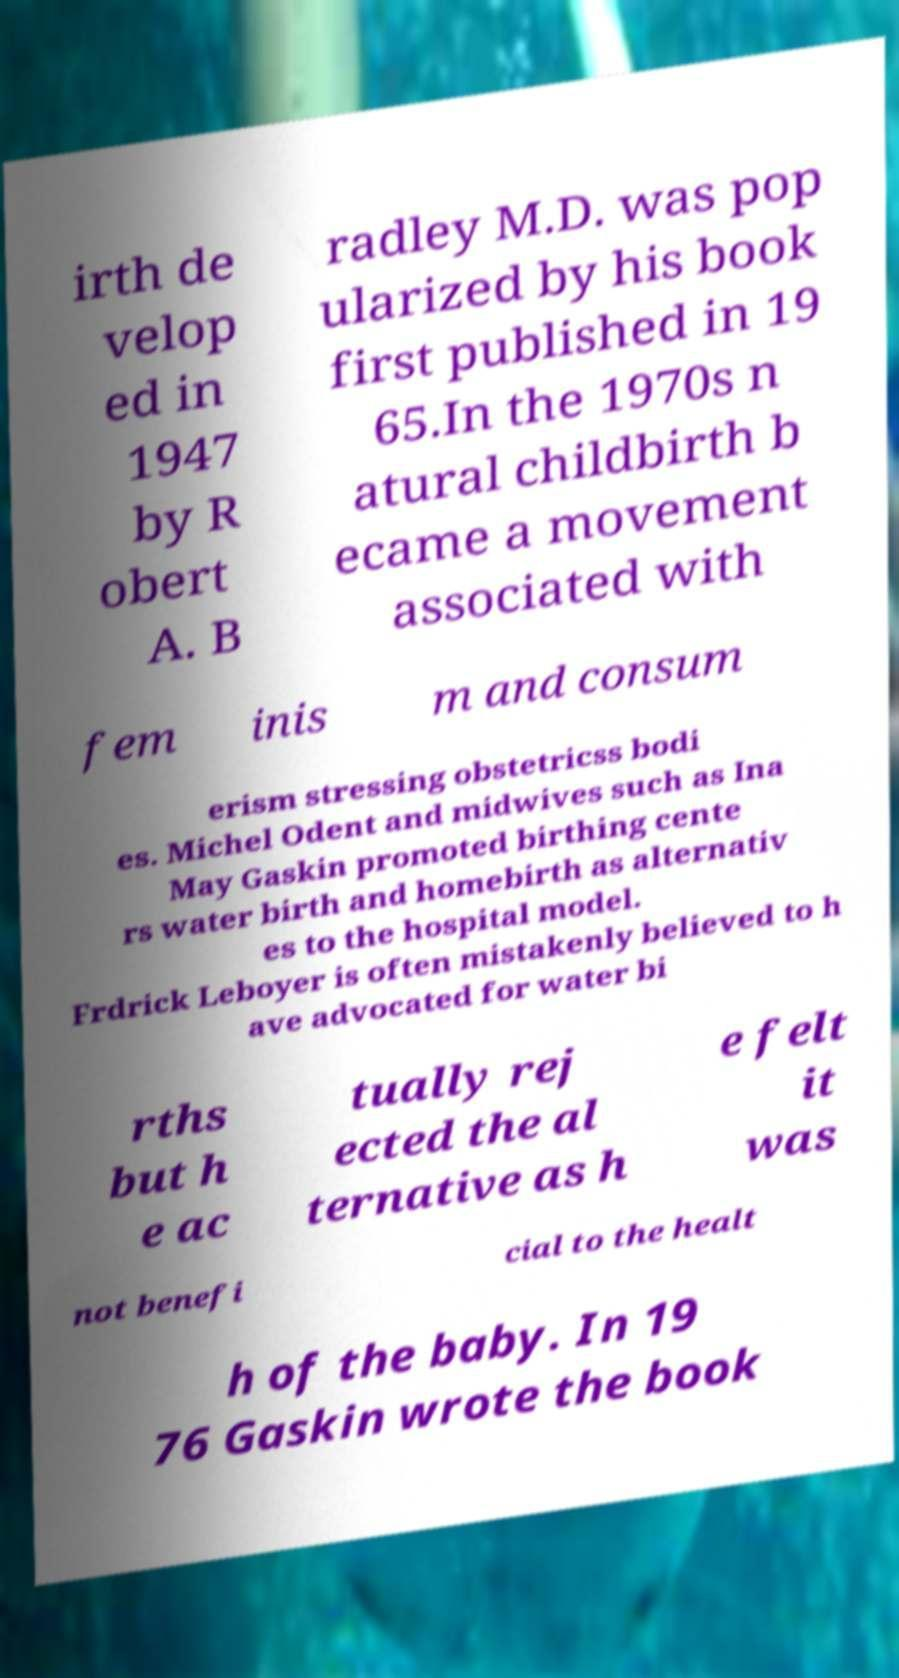Can you accurately transcribe the text from the provided image for me? irth de velop ed in 1947 by R obert A. B radley M.D. was pop ularized by his book first published in 19 65.In the 1970s n atural childbirth b ecame a movement associated with fem inis m and consum erism stressing obstetricss bodi es. Michel Odent and midwives such as Ina May Gaskin promoted birthing cente rs water birth and homebirth as alternativ es to the hospital model. Frdrick Leboyer is often mistakenly believed to h ave advocated for water bi rths but h e ac tually rej ected the al ternative as h e felt it was not benefi cial to the healt h of the baby. In 19 76 Gaskin wrote the book 